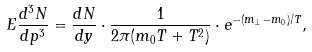Convert formula to latex. <formula><loc_0><loc_0><loc_500><loc_500>E \frac { d ^ { 3 } N } { d p ^ { 3 } } = \frac { d N } { d y } \cdot \frac { 1 } { 2 \pi ( m _ { 0 } T + T ^ { 2 } ) } \cdot e ^ { - ( m _ { \perp } - m _ { 0 } ) / T } ,</formula> 